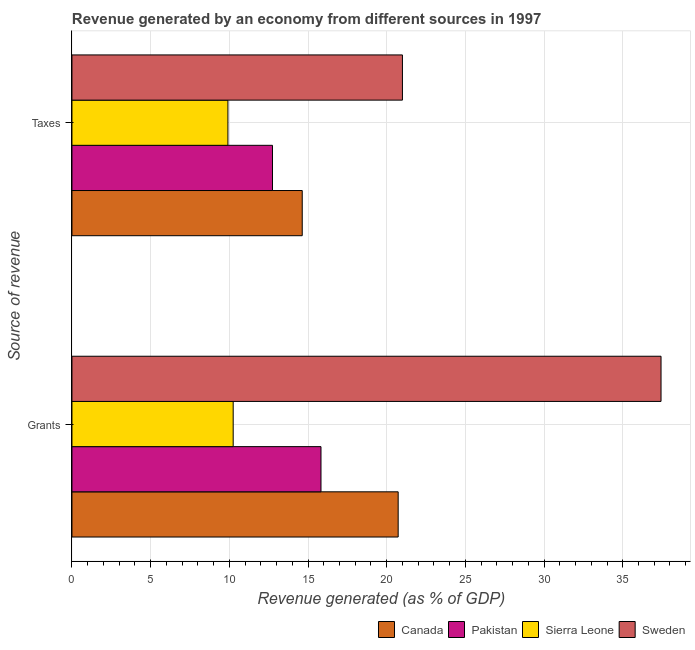How many different coloured bars are there?
Keep it short and to the point. 4. Are the number of bars on each tick of the Y-axis equal?
Keep it short and to the point. Yes. How many bars are there on the 1st tick from the top?
Your answer should be compact. 4. How many bars are there on the 1st tick from the bottom?
Provide a succinct answer. 4. What is the label of the 2nd group of bars from the top?
Keep it short and to the point. Grants. What is the revenue generated by grants in Canada?
Your answer should be very brief. 20.73. Across all countries, what is the maximum revenue generated by grants?
Give a very brief answer. 37.43. Across all countries, what is the minimum revenue generated by grants?
Your answer should be very brief. 10.25. In which country was the revenue generated by taxes minimum?
Your answer should be compact. Sierra Leone. What is the total revenue generated by taxes in the graph?
Give a very brief answer. 58.29. What is the difference between the revenue generated by grants in Pakistan and that in Sweden?
Give a very brief answer. -21.61. What is the difference between the revenue generated by grants in Pakistan and the revenue generated by taxes in Sierra Leone?
Your answer should be compact. 5.91. What is the average revenue generated by taxes per country?
Your response must be concise. 14.57. What is the difference between the revenue generated by taxes and revenue generated by grants in Sweden?
Offer a very short reply. -16.43. In how many countries, is the revenue generated by taxes greater than 27 %?
Offer a terse response. 0. What is the ratio of the revenue generated by grants in Sweden to that in Sierra Leone?
Keep it short and to the point. 3.65. Is the revenue generated by taxes in Canada less than that in Pakistan?
Give a very brief answer. No. What does the 1st bar from the top in Taxes represents?
Ensure brevity in your answer.  Sweden. What does the 3rd bar from the bottom in Grants represents?
Provide a short and direct response. Sierra Leone. Are all the bars in the graph horizontal?
Keep it short and to the point. Yes. What is the difference between two consecutive major ticks on the X-axis?
Your answer should be very brief. 5. Are the values on the major ticks of X-axis written in scientific E-notation?
Offer a very short reply. No. Where does the legend appear in the graph?
Make the answer very short. Bottom right. What is the title of the graph?
Make the answer very short. Revenue generated by an economy from different sources in 1997. Does "Slovenia" appear as one of the legend labels in the graph?
Give a very brief answer. No. What is the label or title of the X-axis?
Provide a succinct answer. Revenue generated (as % of GDP). What is the label or title of the Y-axis?
Make the answer very short. Source of revenue. What is the Revenue generated (as % of GDP) of Canada in Grants?
Give a very brief answer. 20.73. What is the Revenue generated (as % of GDP) in Pakistan in Grants?
Give a very brief answer. 15.82. What is the Revenue generated (as % of GDP) in Sierra Leone in Grants?
Make the answer very short. 10.25. What is the Revenue generated (as % of GDP) of Sweden in Grants?
Ensure brevity in your answer.  37.43. What is the Revenue generated (as % of GDP) in Canada in Taxes?
Your answer should be compact. 14.63. What is the Revenue generated (as % of GDP) in Pakistan in Taxes?
Your answer should be compact. 12.74. What is the Revenue generated (as % of GDP) in Sierra Leone in Taxes?
Make the answer very short. 9.91. What is the Revenue generated (as % of GDP) in Sweden in Taxes?
Your answer should be compact. 21. Across all Source of revenue, what is the maximum Revenue generated (as % of GDP) in Canada?
Your answer should be very brief. 20.73. Across all Source of revenue, what is the maximum Revenue generated (as % of GDP) of Pakistan?
Your response must be concise. 15.82. Across all Source of revenue, what is the maximum Revenue generated (as % of GDP) of Sierra Leone?
Ensure brevity in your answer.  10.25. Across all Source of revenue, what is the maximum Revenue generated (as % of GDP) in Sweden?
Your response must be concise. 37.43. Across all Source of revenue, what is the minimum Revenue generated (as % of GDP) of Canada?
Give a very brief answer. 14.63. Across all Source of revenue, what is the minimum Revenue generated (as % of GDP) in Pakistan?
Make the answer very short. 12.74. Across all Source of revenue, what is the minimum Revenue generated (as % of GDP) in Sierra Leone?
Your answer should be very brief. 9.91. Across all Source of revenue, what is the minimum Revenue generated (as % of GDP) in Sweden?
Offer a terse response. 21. What is the total Revenue generated (as % of GDP) in Canada in the graph?
Offer a terse response. 35.36. What is the total Revenue generated (as % of GDP) in Pakistan in the graph?
Ensure brevity in your answer.  28.57. What is the total Revenue generated (as % of GDP) of Sierra Leone in the graph?
Your answer should be very brief. 20.16. What is the total Revenue generated (as % of GDP) in Sweden in the graph?
Offer a very short reply. 58.43. What is the difference between the Revenue generated (as % of GDP) of Canada in Grants and that in Taxes?
Give a very brief answer. 6.1. What is the difference between the Revenue generated (as % of GDP) in Pakistan in Grants and that in Taxes?
Provide a short and direct response. 3.08. What is the difference between the Revenue generated (as % of GDP) in Sierra Leone in Grants and that in Taxes?
Ensure brevity in your answer.  0.33. What is the difference between the Revenue generated (as % of GDP) of Sweden in Grants and that in Taxes?
Offer a terse response. 16.43. What is the difference between the Revenue generated (as % of GDP) in Canada in Grants and the Revenue generated (as % of GDP) in Pakistan in Taxes?
Your answer should be compact. 7.99. What is the difference between the Revenue generated (as % of GDP) in Canada in Grants and the Revenue generated (as % of GDP) in Sierra Leone in Taxes?
Provide a succinct answer. 10.82. What is the difference between the Revenue generated (as % of GDP) of Canada in Grants and the Revenue generated (as % of GDP) of Sweden in Taxes?
Ensure brevity in your answer.  -0.27. What is the difference between the Revenue generated (as % of GDP) in Pakistan in Grants and the Revenue generated (as % of GDP) in Sierra Leone in Taxes?
Give a very brief answer. 5.91. What is the difference between the Revenue generated (as % of GDP) in Pakistan in Grants and the Revenue generated (as % of GDP) in Sweden in Taxes?
Your response must be concise. -5.18. What is the difference between the Revenue generated (as % of GDP) in Sierra Leone in Grants and the Revenue generated (as % of GDP) in Sweden in Taxes?
Your response must be concise. -10.75. What is the average Revenue generated (as % of GDP) of Canada per Source of revenue?
Keep it short and to the point. 17.68. What is the average Revenue generated (as % of GDP) of Pakistan per Source of revenue?
Ensure brevity in your answer.  14.28. What is the average Revenue generated (as % of GDP) in Sierra Leone per Source of revenue?
Offer a very short reply. 10.08. What is the average Revenue generated (as % of GDP) of Sweden per Source of revenue?
Give a very brief answer. 29.22. What is the difference between the Revenue generated (as % of GDP) in Canada and Revenue generated (as % of GDP) in Pakistan in Grants?
Your response must be concise. 4.9. What is the difference between the Revenue generated (as % of GDP) in Canada and Revenue generated (as % of GDP) in Sierra Leone in Grants?
Offer a terse response. 10.48. What is the difference between the Revenue generated (as % of GDP) of Canada and Revenue generated (as % of GDP) of Sweden in Grants?
Offer a terse response. -16.7. What is the difference between the Revenue generated (as % of GDP) of Pakistan and Revenue generated (as % of GDP) of Sierra Leone in Grants?
Your answer should be very brief. 5.58. What is the difference between the Revenue generated (as % of GDP) of Pakistan and Revenue generated (as % of GDP) of Sweden in Grants?
Offer a very short reply. -21.61. What is the difference between the Revenue generated (as % of GDP) of Sierra Leone and Revenue generated (as % of GDP) of Sweden in Grants?
Offer a very short reply. -27.19. What is the difference between the Revenue generated (as % of GDP) in Canada and Revenue generated (as % of GDP) in Pakistan in Taxes?
Provide a short and direct response. 1.89. What is the difference between the Revenue generated (as % of GDP) in Canada and Revenue generated (as % of GDP) in Sierra Leone in Taxes?
Offer a terse response. 4.72. What is the difference between the Revenue generated (as % of GDP) in Canada and Revenue generated (as % of GDP) in Sweden in Taxes?
Your answer should be compact. -6.37. What is the difference between the Revenue generated (as % of GDP) of Pakistan and Revenue generated (as % of GDP) of Sierra Leone in Taxes?
Make the answer very short. 2.83. What is the difference between the Revenue generated (as % of GDP) in Pakistan and Revenue generated (as % of GDP) in Sweden in Taxes?
Give a very brief answer. -8.26. What is the difference between the Revenue generated (as % of GDP) of Sierra Leone and Revenue generated (as % of GDP) of Sweden in Taxes?
Offer a very short reply. -11.09. What is the ratio of the Revenue generated (as % of GDP) of Canada in Grants to that in Taxes?
Offer a very short reply. 1.42. What is the ratio of the Revenue generated (as % of GDP) of Pakistan in Grants to that in Taxes?
Provide a succinct answer. 1.24. What is the ratio of the Revenue generated (as % of GDP) in Sierra Leone in Grants to that in Taxes?
Ensure brevity in your answer.  1.03. What is the ratio of the Revenue generated (as % of GDP) in Sweden in Grants to that in Taxes?
Ensure brevity in your answer.  1.78. What is the difference between the highest and the second highest Revenue generated (as % of GDP) in Canada?
Make the answer very short. 6.1. What is the difference between the highest and the second highest Revenue generated (as % of GDP) of Pakistan?
Your answer should be very brief. 3.08. What is the difference between the highest and the second highest Revenue generated (as % of GDP) in Sierra Leone?
Make the answer very short. 0.33. What is the difference between the highest and the second highest Revenue generated (as % of GDP) in Sweden?
Make the answer very short. 16.43. What is the difference between the highest and the lowest Revenue generated (as % of GDP) of Canada?
Your response must be concise. 6.1. What is the difference between the highest and the lowest Revenue generated (as % of GDP) in Pakistan?
Make the answer very short. 3.08. What is the difference between the highest and the lowest Revenue generated (as % of GDP) in Sierra Leone?
Make the answer very short. 0.33. What is the difference between the highest and the lowest Revenue generated (as % of GDP) in Sweden?
Provide a succinct answer. 16.43. 